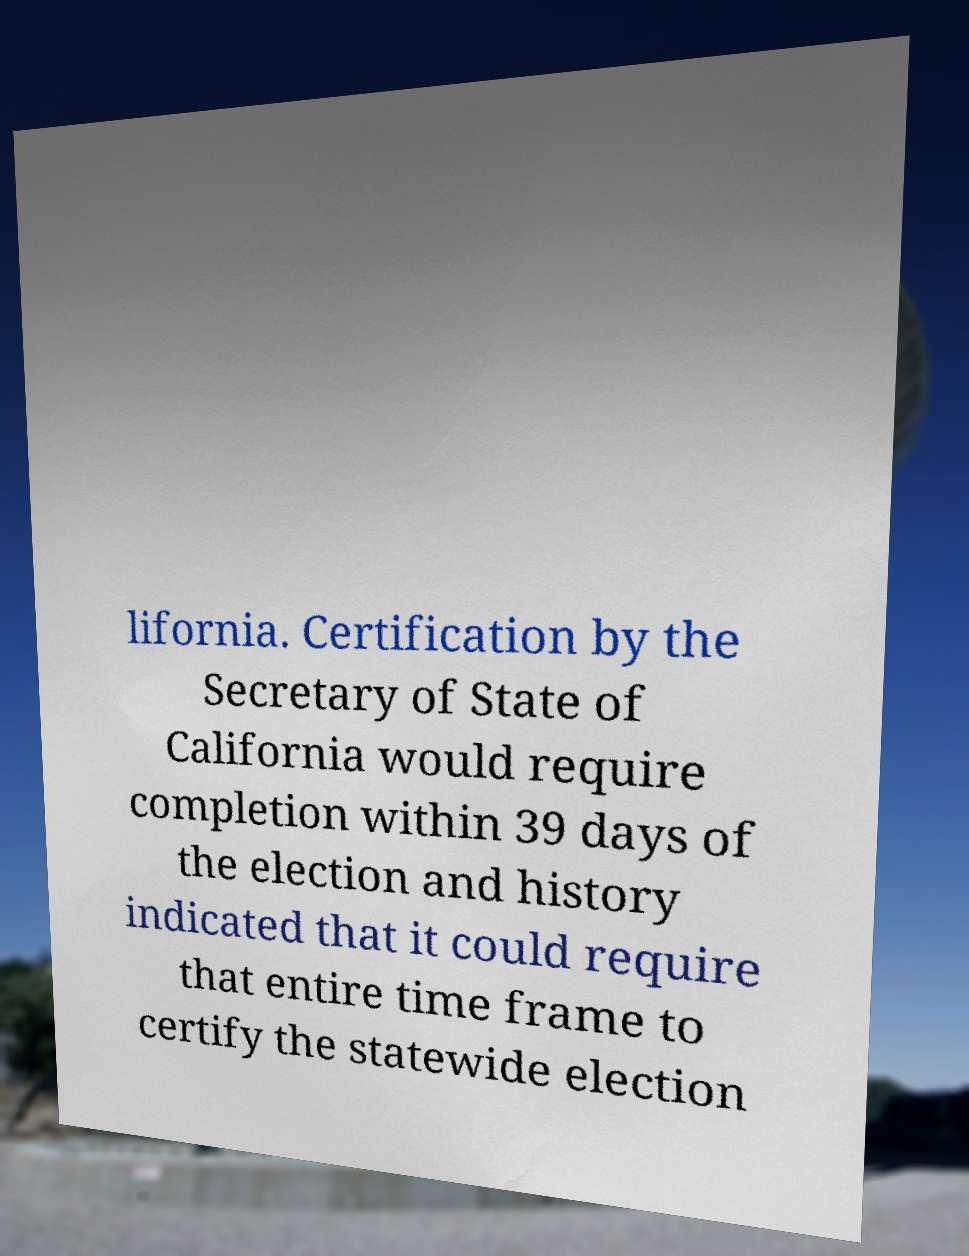Please identify and transcribe the text found in this image. lifornia. Certification by the Secretary of State of California would require completion within 39 days of the election and history indicated that it could require that entire time frame to certify the statewide election 